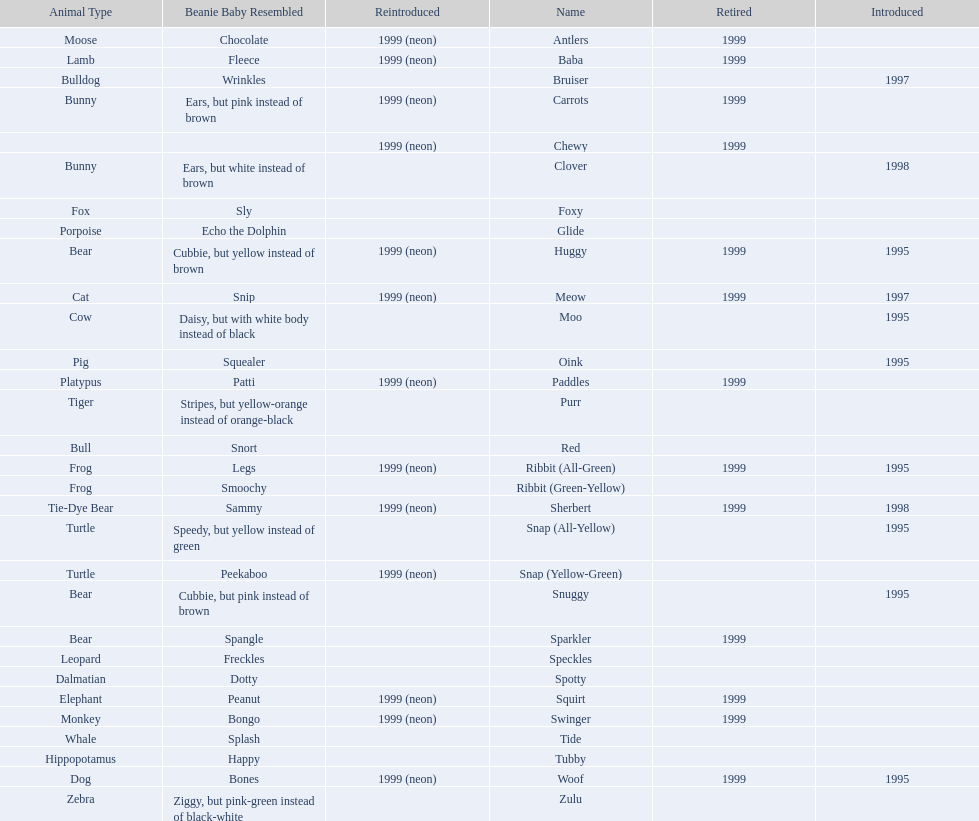What is the combined number of reintroduced and retired pillow pals in 1999? 12. 